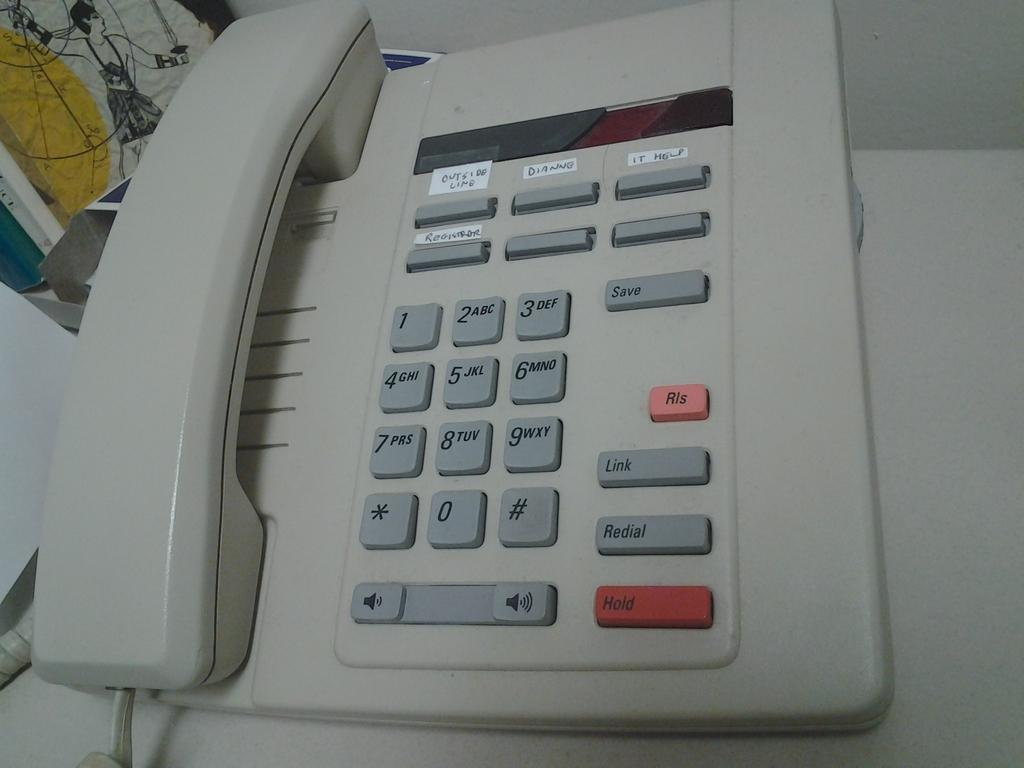What object is the main focus of the image? There is a white telephone in the image. What feature does the telephone have? The telephone has buttons. Where is the telephone located? The telephone is placed on a desk. What else can be seen on the desk? There are other things placed on the desk. Can you tell me how many horses are visible on the desk in the image? There are no horses present in the image, as it features a white telephone on a desk with other unspecified objects. What type of sugar is being used to sweeten the throat in the image? There is no sugar or reference to a throat in the image; it only shows a white telephone on a desk. 